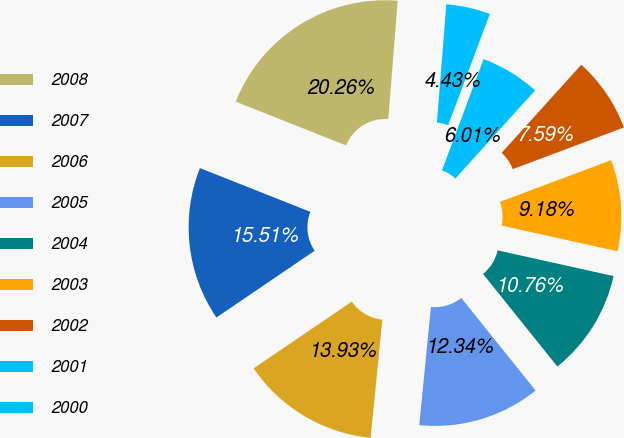Convert chart to OTSL. <chart><loc_0><loc_0><loc_500><loc_500><pie_chart><fcel>2008<fcel>2007<fcel>2006<fcel>2005<fcel>2004<fcel>2003<fcel>2002<fcel>2001<fcel>2000<nl><fcel>20.26%<fcel>15.51%<fcel>13.93%<fcel>12.34%<fcel>10.76%<fcel>9.18%<fcel>7.59%<fcel>6.01%<fcel>4.43%<nl></chart> 